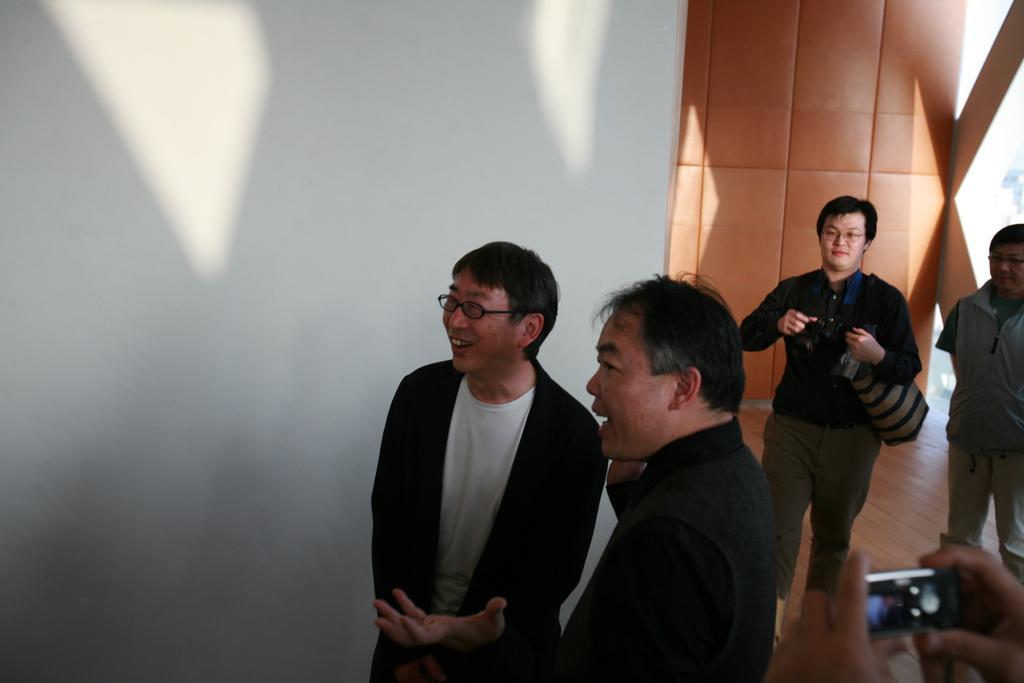Please provide a concise description of this image. In the picture we can find see some people are standing on the floor and one man is holding a bag and we can see also some hands holding a camera, in background we can find a white wall. 